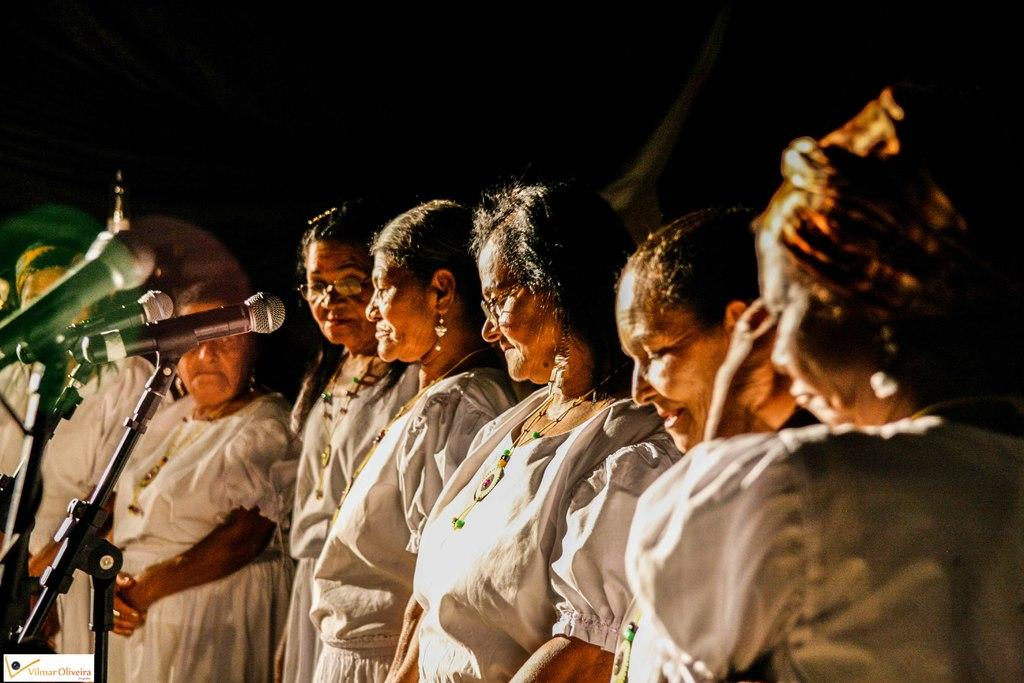What is the main subject of the image? The main subject of the image is a group of old ladies. What are the old ladies wearing in the image? The old ladies are wearing white dresses in the image. What activity are the old ladies engaged in? The old ladies are singing into microphones in the image. What is the color of the background in the image? The background in the image is black. Can you see any grass growing in the image? No, there is no grass visible in the image. What type of current is flowing through the microphones in the image? There is no information about any current in the image; the focus is on the old ladies singing into microphones. 